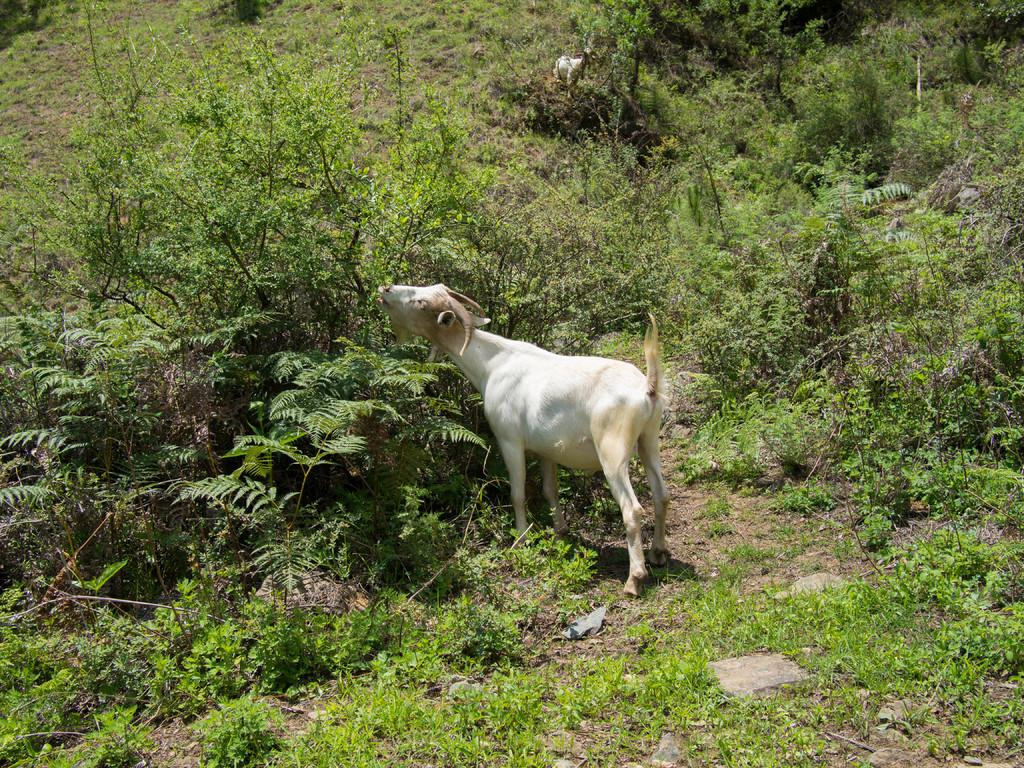What animal can be seen in the image? There is a goat in the image. What is the goat doing in the image? The goat is eating leaves from a plant. What type of vegetation is around the goat? There is grass around the goat. What other types of plants are present in the image? There are different plants in the image. Can you describe the other animal in the distance? Unfortunately, the facts provided do not give enough information to describe the other animal in the distance. What type of polish is the goat using to eat the leaves in the image? The goat is not using any polish to eat the leaves; it is simply eating them directly from the plant. Can you describe the sofa in the image? There is no sofa present in the image. 